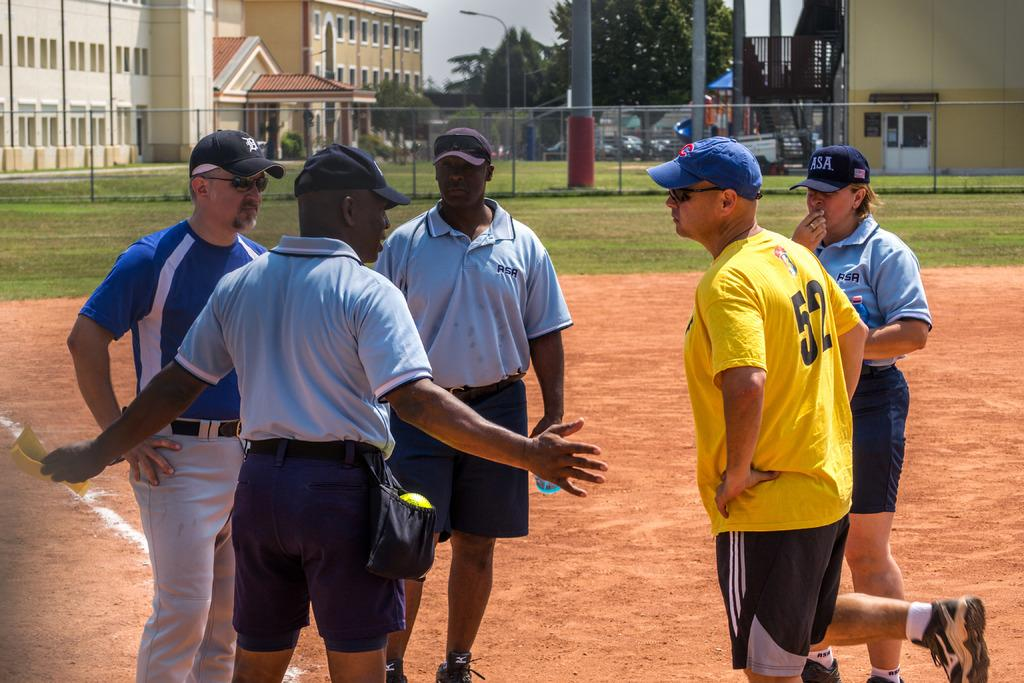<image>
Describe the image concisely. Number 52 listens to the umpire while standing near home plate. 